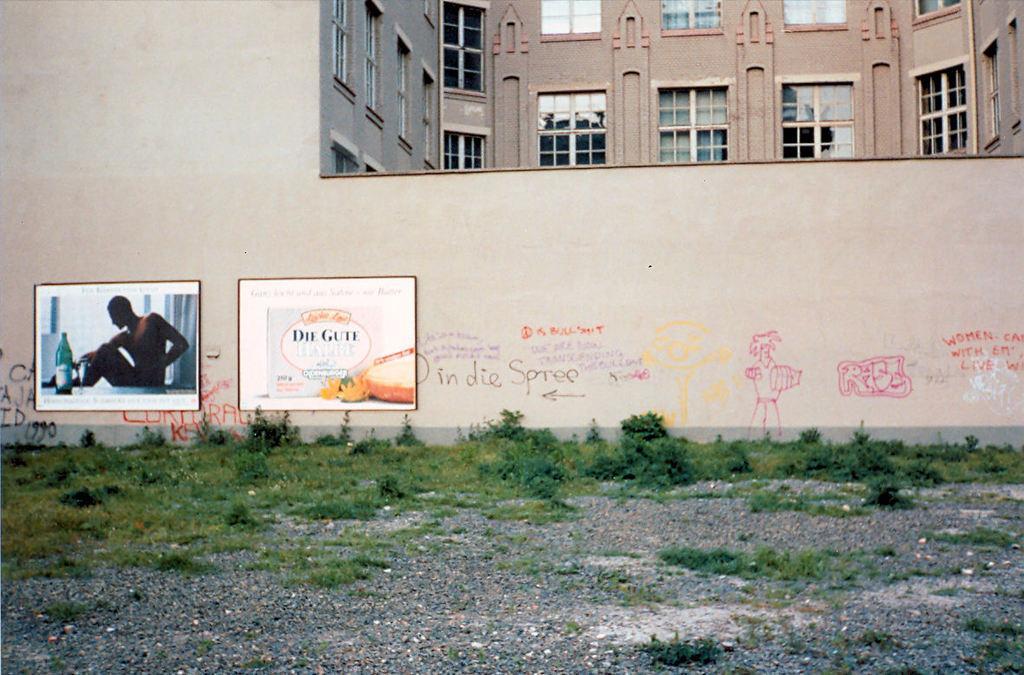In one or two sentences, can you explain what this image depicts? In the center of the image there is a building, wall, windows, frames, grass and stones. On the frames, we can see one bottle, one person, some text and a few other objects. And we can see some text and some drawings on the wall. 